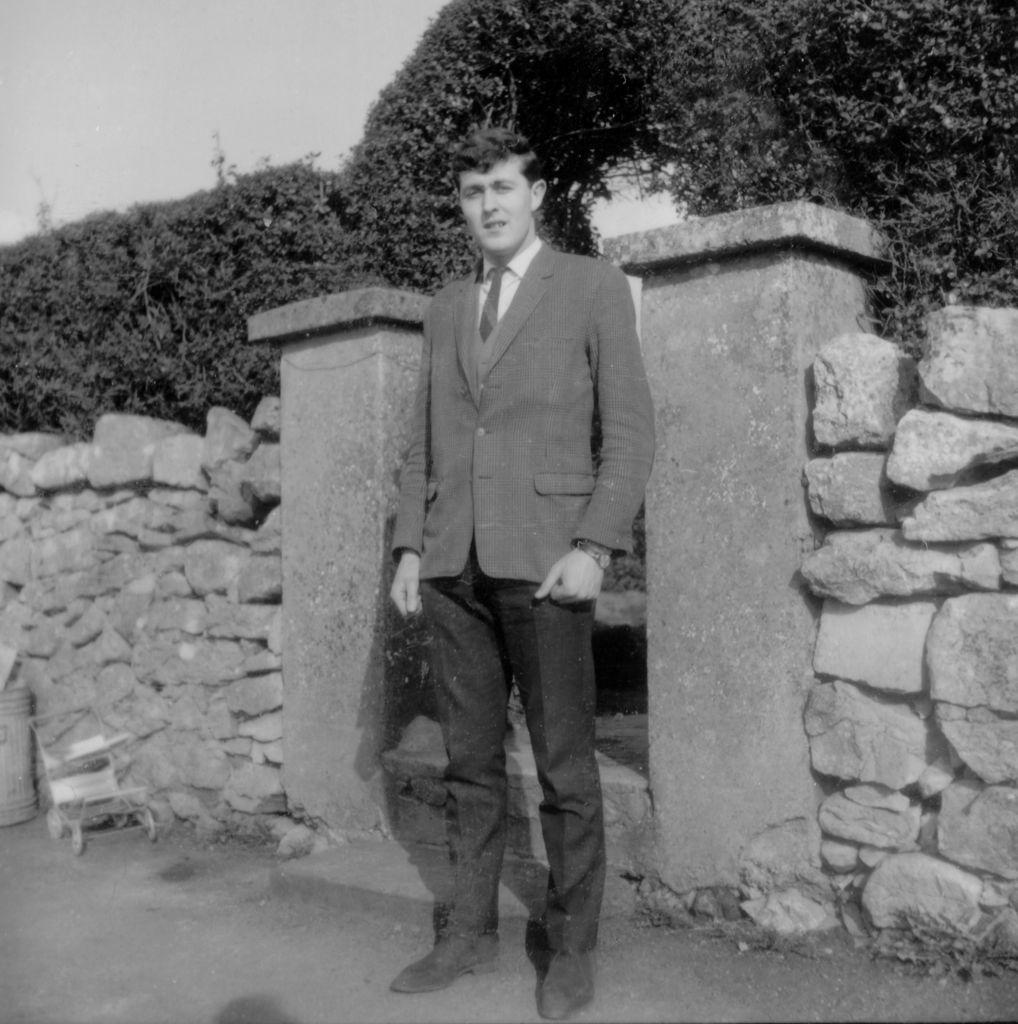What is the person in the image doing? There is a person standing on the ground in the image. What object can be seen for disposing of waste in the image? There is a dustbin in the image. What type of vehicle is present in the image? There is a stroller in the image, which is not a vehicle but a mode of transport for a child. What is visible in the background of the image? There is a wall, an arch with creeper plants, and the sky visible in the background of the image. What type of tank is visible in the image? There is no tank present in the image. What shape is the stroller in the image? The stroller in the image is not a specific shape, but it has a frame and wheels for transporting a child. 